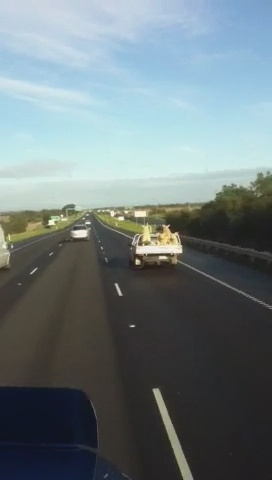Describe the objects in this image and their specific colors. I can see truck in lightgray, ivory, tan, gray, and black tones, truck in lightgray, darkgray, gray, and beige tones, car in lightgray, gray, ivory, darkgray, and black tones, car in gray and lightgray tones, and car in darkgray, gray, and lightgray tones in this image. 